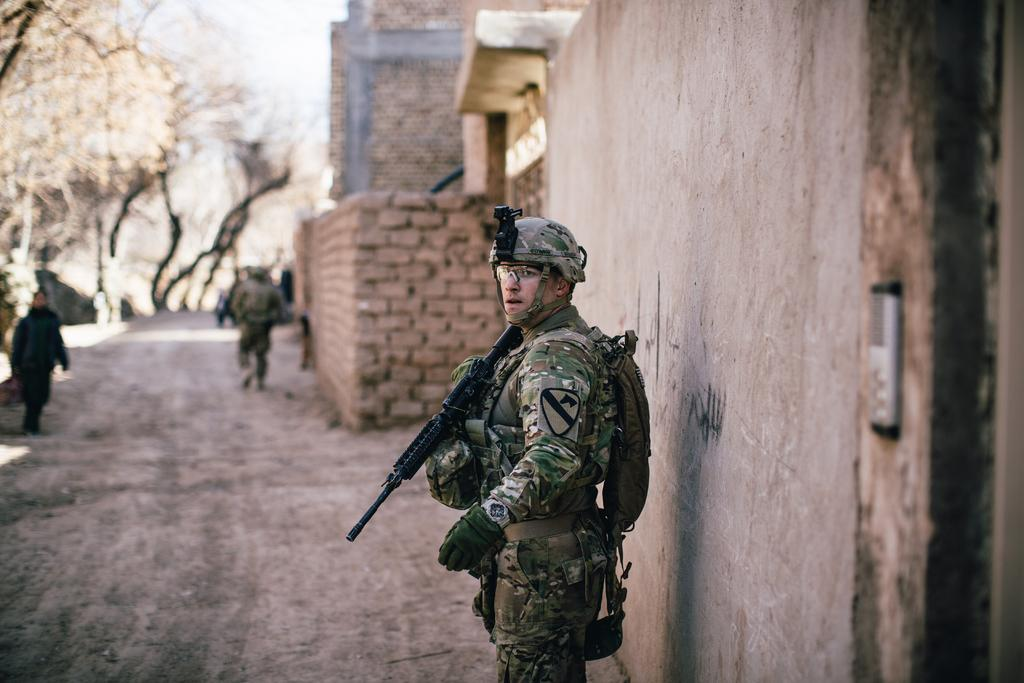What is the person in the image holding? The person in the image is holding a gun. What can be seen on the right side of the image? There is a wall on the right side of the image. What is visible in the background of the image? There is a building, trees, and the sky visible in the background of the image. Are there any other people in the image? Yes, there are other persons in the background of the image. What type of bear can be seen interacting with the person holding the gun in the image? There is no bear present in the image; it only features a person holding a gun and other elements mentioned in the facts. 